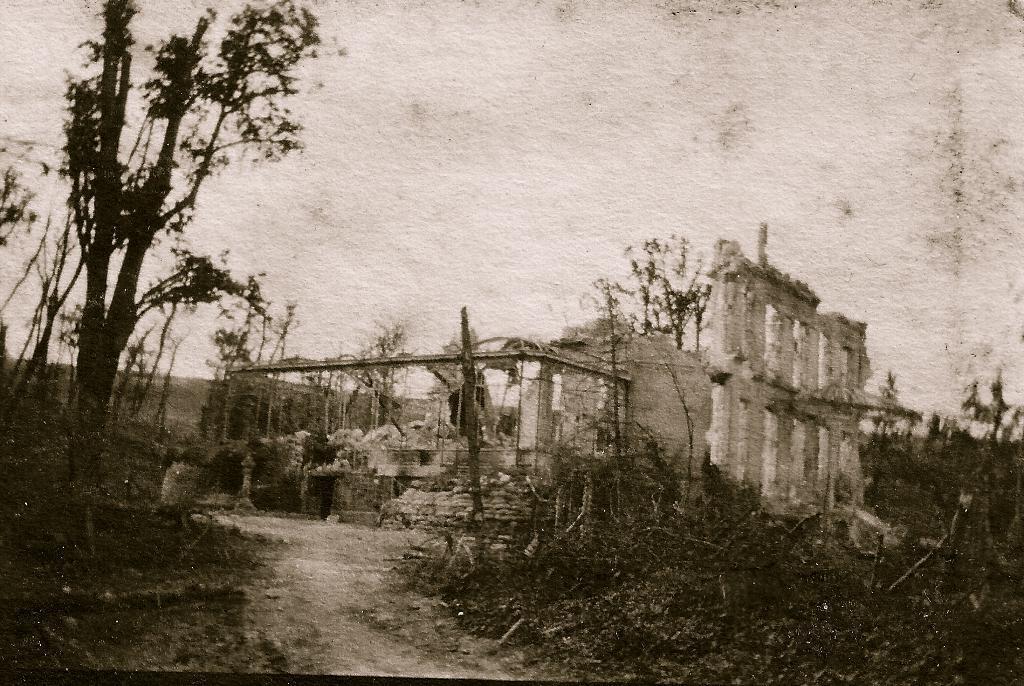Can you describe this image briefly? In this image there are plants , trees, a collapsed house, and in the background there is sky. 